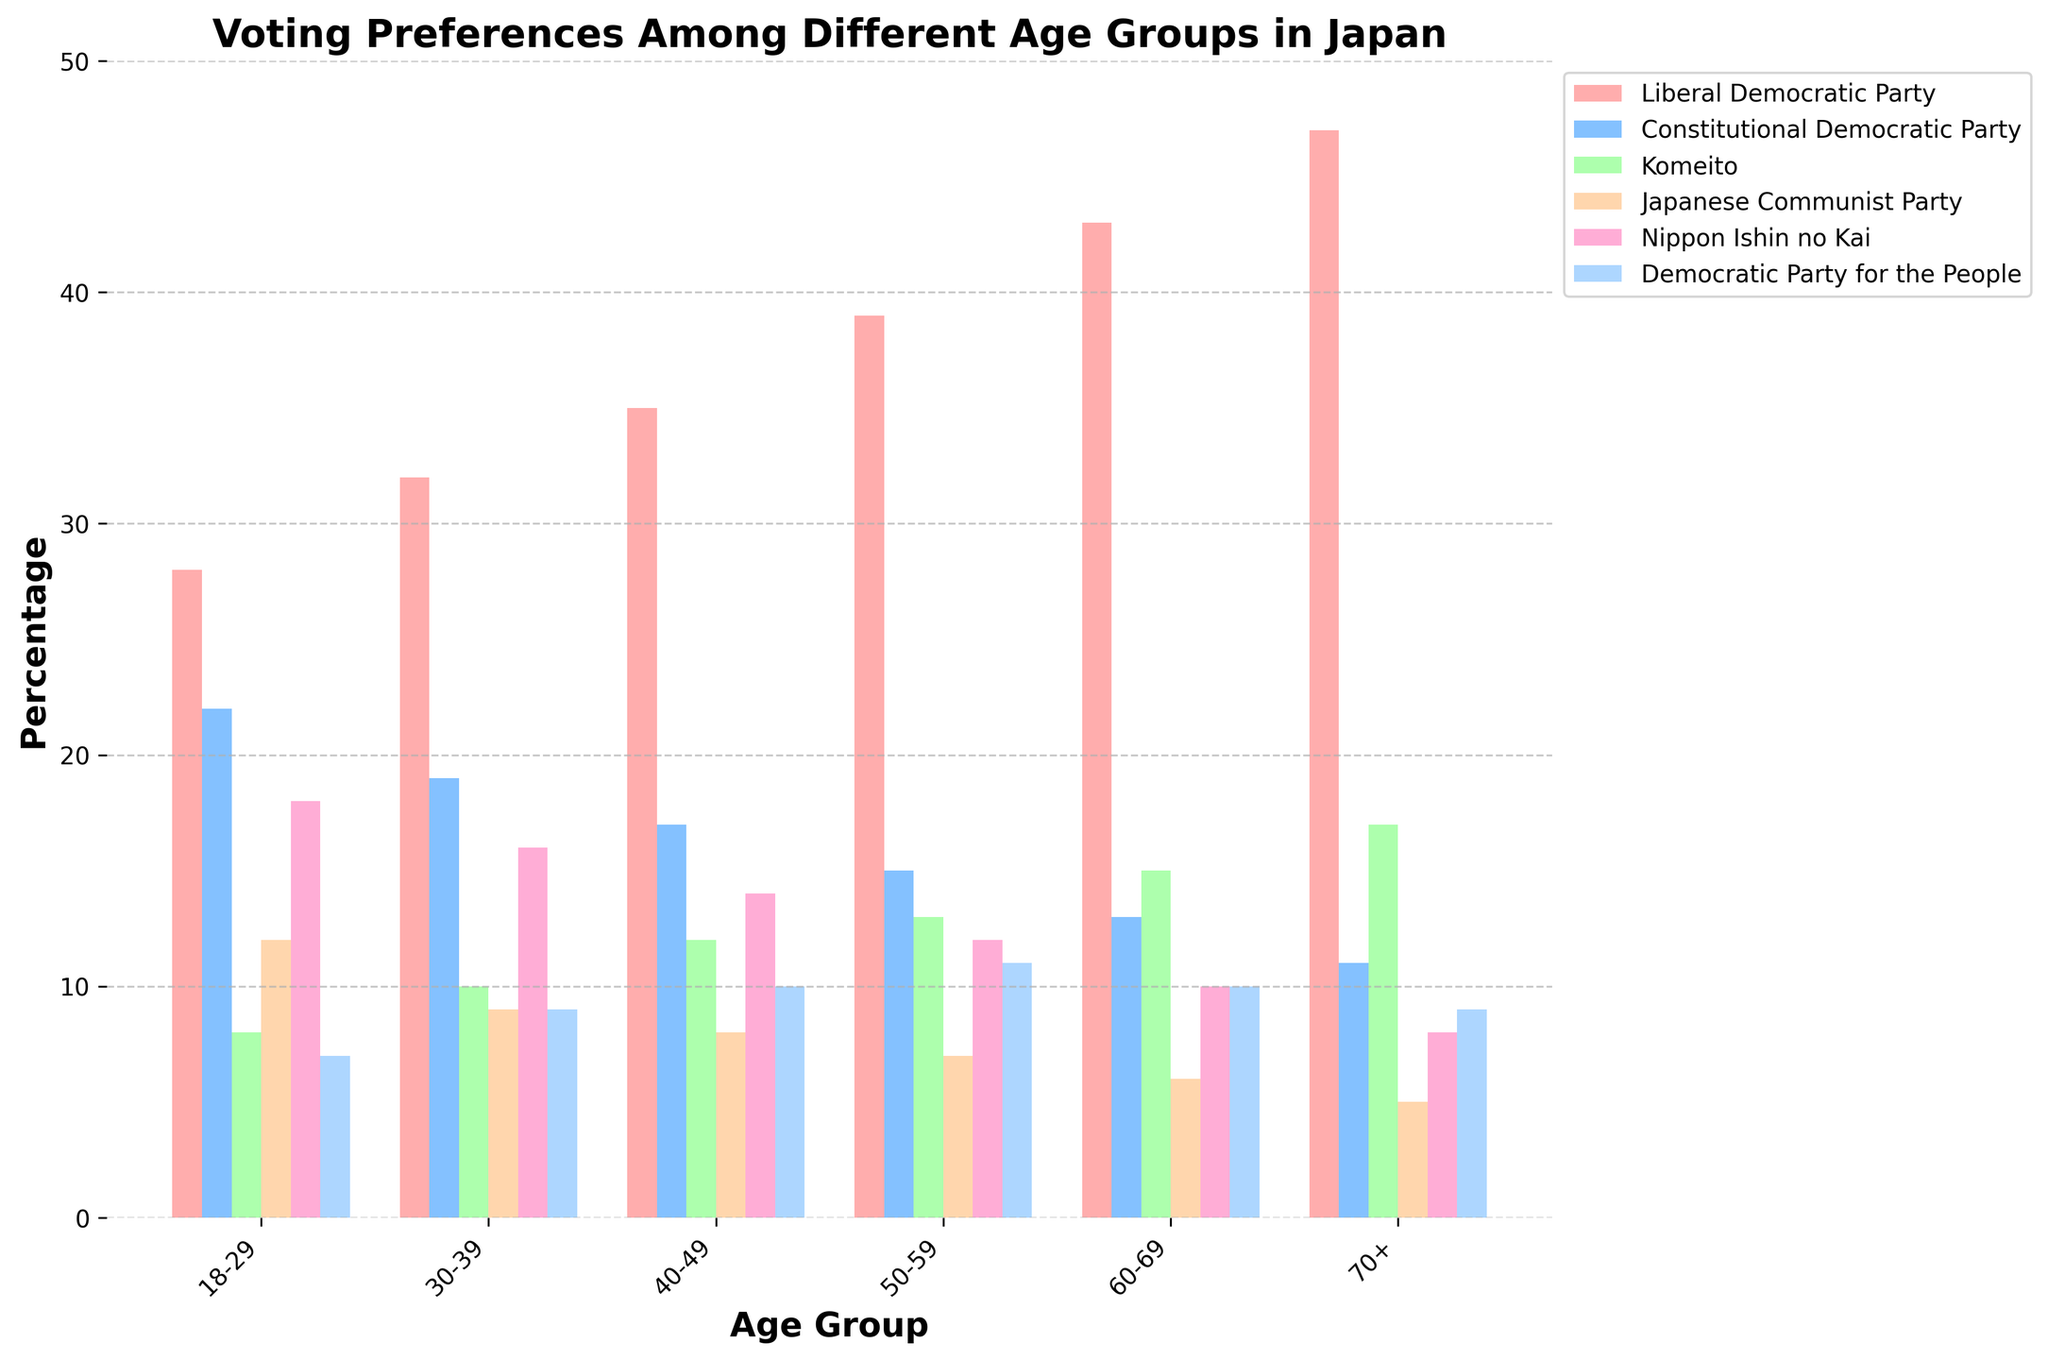Which age group shows the highest preference for the Liberal Democratic Party? The figure shows bars for different age groups colored in shades, and the tallest bar for the Liberal Democratic Party is in the 70+ age group.
Answer: 70+ Which party do the 18-29 age group prefer the second most? The second tallest bar for the 18-29 age group is for the Constitutional Democratic Party, as indicated by its height relative to other bars in that group.
Answer: Constitutional Democratic Party What is the difference in support for the Komeito party between the 60-69 and 70+ age groups? By comparing the height of the Komeito bars for the two age groups, we see that the bar for the 60-69 age group is marked at 15, and for the 70+ age group, it's at 17. Therefore, the difference is 17 - 15.
Answer: 2 Which party has the least amount of support in the 30-39 age group, and what is the percentage? Among the bars for the 30-39 age group, the shortest one corresponds to the Japanese Communist Party, which stands at 9%.
Answer: Japanese Communist Party, 9% Does any party have consistent support across all age groups? By observing each party's bar across different age groups, we notice that the support for the Democratic Party for the People remains relatively consistent as its bars show only minor variations between 7% and 11%.
Answer: Democratic Party for the People What is the average percentage of support for the Japanese Communist Party across all age groups? Summing up the support percentages for the Japanese Communist Party from all age groups (12, 9, 8, 7, 6, 5) gives 47. Dividing this total by the number of age groups, which is 6, we get an average of 47/6.
Answer: 7.83 How does support for the Nippon Ishin no Kai change from the 18-29 age group to the 70+ age group? Looking at the bars for the Nippon Ishin no Kai, we see that the support decreases as age increases, starting from 18% in the 18-29 group and reducing to 8% in the 70+ group.
Answer: Decreases What are the two age groups with the closest level of support for the Democratic Party for the People? By comparing the Democratic Party for the People bars, we observe that the 18-29 age group (7%) and the 40-49 age group (10%) have among the closest levels of support. The next closest pair would be 50-59 and 60-69, both with 10%.
Answer: 50-59 and 60-69 